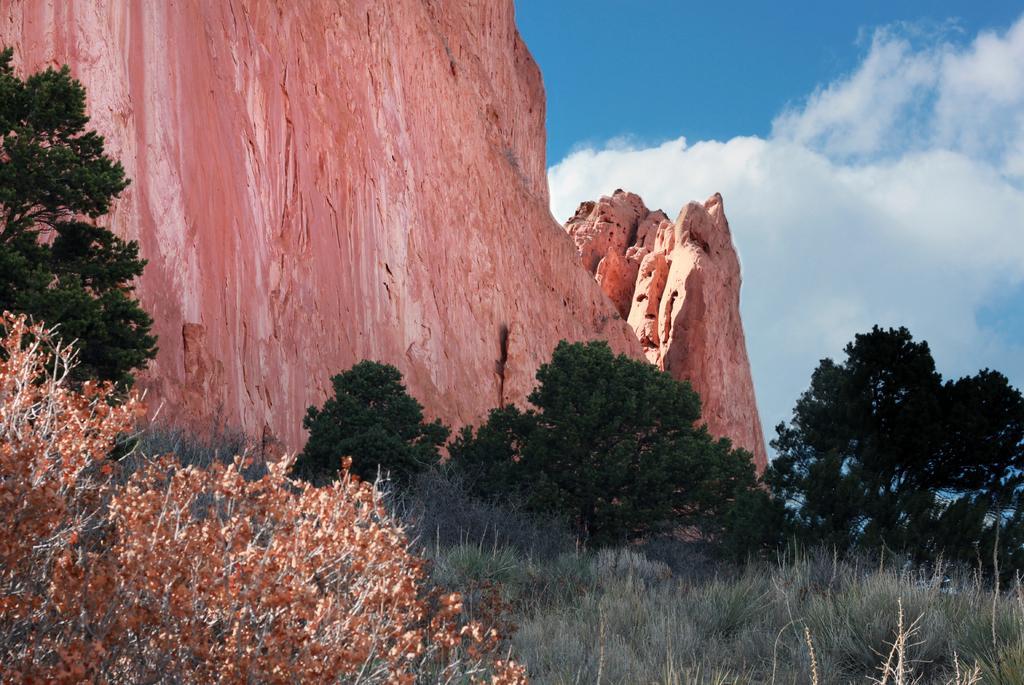How would you summarize this image in a sentence or two? In the picture I can see the grass, trees, stone hills and the blue color sky with clouds in the background. 